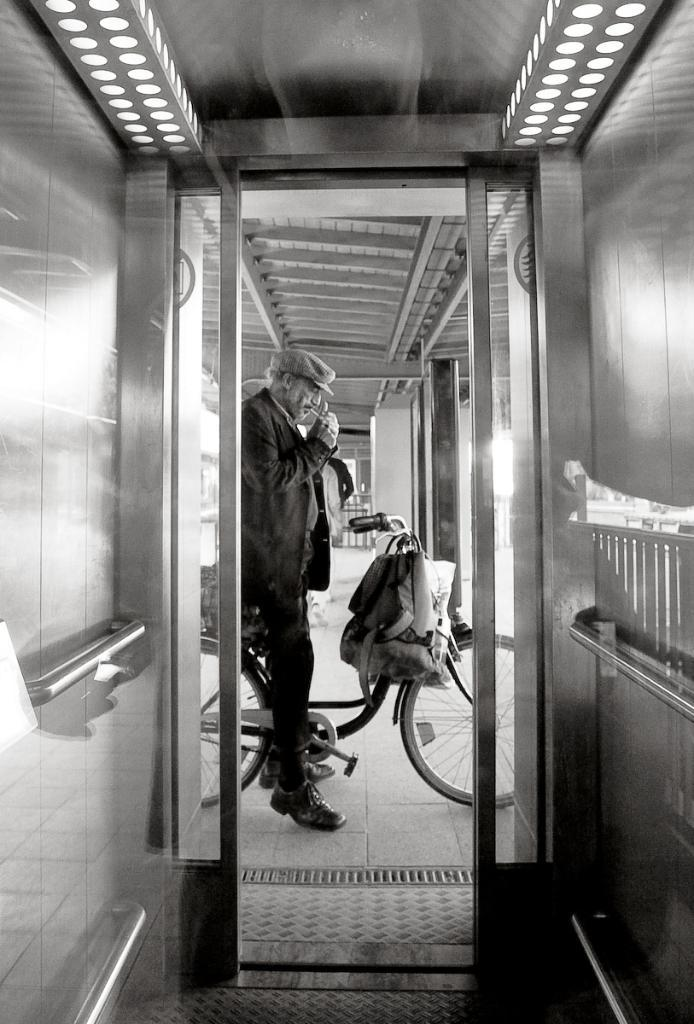What is the color scheme of the image? The image is black and white. What is the person in the image doing? The person is sitting on a bicycle in the image. Is there any additional item on the bicycle? Yes, there is a bag on the bicycle in the image. How many snakes are wrapped around the person's legs in the image? There are no snakes present in the image; the person is sitting on a bicycle with a bag on it. 